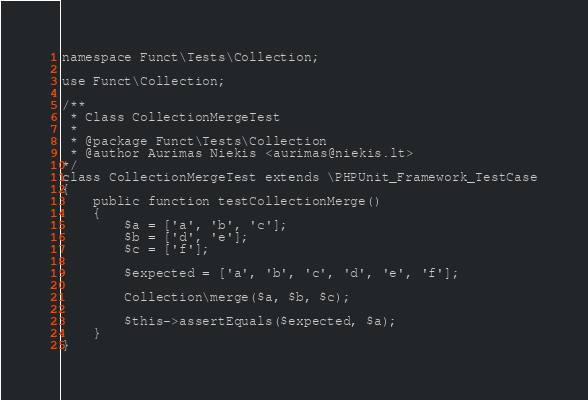<code> <loc_0><loc_0><loc_500><loc_500><_PHP_>
namespace Funct\Tests\Collection;

use Funct\Collection;

/**
 * Class CollectionMergeTest
 *
 * @package Funct\Tests\Collection
 * @author Aurimas Niekis <aurimas@niekis.lt>
*/
class CollectionMergeTest extends \PHPUnit_Framework_TestCase
{
    public function testCollectionMerge()
    {
        $a = ['a', 'b', 'c'];
        $b = ['d', 'e'];
        $c = ['f'];

        $expected = ['a', 'b', 'c', 'd', 'e', 'f'];

        Collection\merge($a, $b, $c);

        $this->assertEquals($expected, $a);
    }
}
</code> 